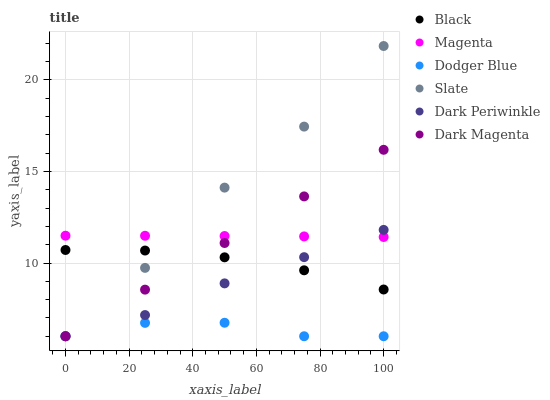Does Dodger Blue have the minimum area under the curve?
Answer yes or no. Yes. Does Slate have the maximum area under the curve?
Answer yes or no. Yes. Does Slate have the minimum area under the curve?
Answer yes or no. No. Does Dodger Blue have the maximum area under the curve?
Answer yes or no. No. Is Dark Magenta the smoothest?
Answer yes or no. Yes. Is Slate the roughest?
Answer yes or no. Yes. Is Dodger Blue the smoothest?
Answer yes or no. No. Is Dodger Blue the roughest?
Answer yes or no. No. Does Dark Magenta have the lowest value?
Answer yes or no. Yes. Does Black have the lowest value?
Answer yes or no. No. Does Slate have the highest value?
Answer yes or no. Yes. Does Dodger Blue have the highest value?
Answer yes or no. No. Is Dodger Blue less than Magenta?
Answer yes or no. Yes. Is Magenta greater than Dodger Blue?
Answer yes or no. Yes. Does Magenta intersect Slate?
Answer yes or no. Yes. Is Magenta less than Slate?
Answer yes or no. No. Is Magenta greater than Slate?
Answer yes or no. No. Does Dodger Blue intersect Magenta?
Answer yes or no. No. 